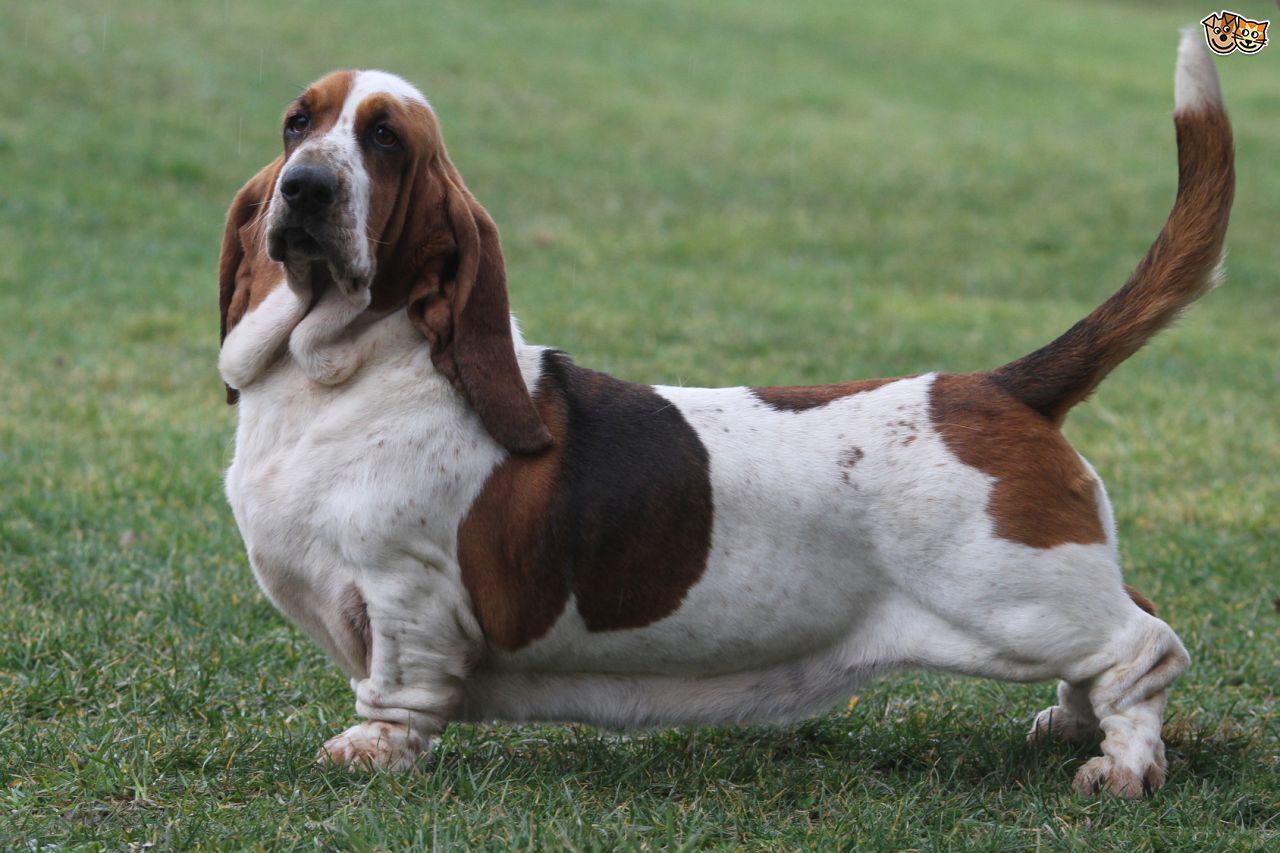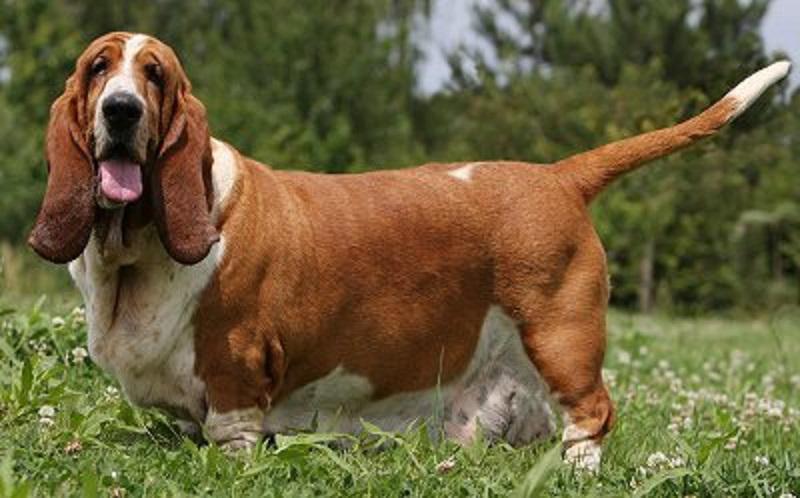The first image is the image on the left, the second image is the image on the right. For the images displayed, is the sentence "a dog is standing in the grass facing left'" factually correct? Answer yes or no. Yes. The first image is the image on the left, the second image is the image on the right. Considering the images on both sides, is "At least one dog is standing on the grass." valid? Answer yes or no. Yes. 